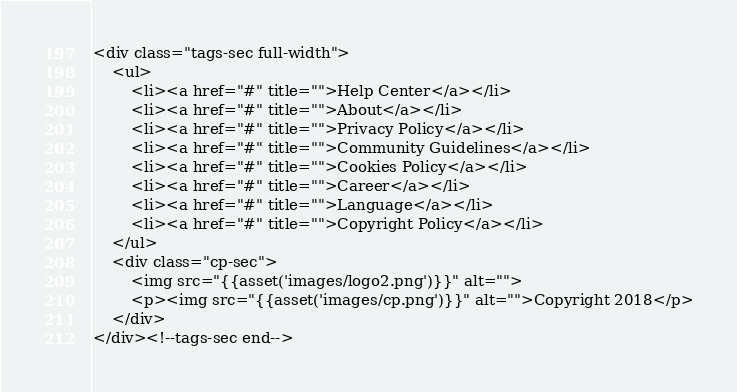Convert code to text. <code><loc_0><loc_0><loc_500><loc_500><_PHP_><div class="tags-sec full-width">
    <ul>
        <li><a href="#" title="">Help Center</a></li>
        <li><a href="#" title="">About</a></li>
        <li><a href="#" title="">Privacy Policy</a></li>
        <li><a href="#" title="">Community Guidelines</a></li>
        <li><a href="#" title="">Cookies Policy</a></li>
        <li><a href="#" title="">Career</a></li>
        <li><a href="#" title="">Language</a></li>
        <li><a href="#" title="">Copyright Policy</a></li>
    </ul>
    <div class="cp-sec">
        <img src="{{asset('images/logo2.png')}}" alt="">
        <p><img src="{{asset('images/cp.png')}}" alt="">Copyright 2018</p>
    </div>
</div><!--tags-sec end--></code> 